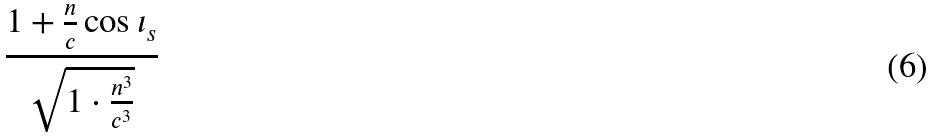<formula> <loc_0><loc_0><loc_500><loc_500>\frac { 1 + \frac { n } { c } \cos \iota _ { s } } { \sqrt { 1 \cdot \frac { n ^ { 3 } } { c ^ { 3 } } } }</formula> 